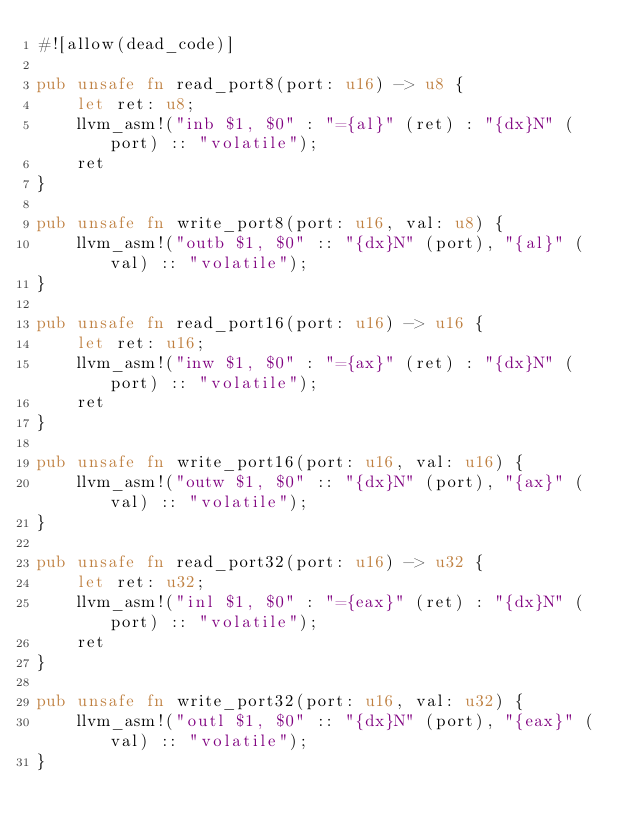Convert code to text. <code><loc_0><loc_0><loc_500><loc_500><_Rust_>#![allow(dead_code)]

pub unsafe fn read_port8(port: u16) -> u8 {
    let ret: u8;
    llvm_asm!("inb $1, $0" : "={al}" (ret) : "{dx}N" (port) :: "volatile");
    ret
}

pub unsafe fn write_port8(port: u16, val: u8) {
    llvm_asm!("outb $1, $0" :: "{dx}N" (port), "{al}" (val) :: "volatile");
}

pub unsafe fn read_port16(port: u16) -> u16 {
    let ret: u16;
    llvm_asm!("inw $1, $0" : "={ax}" (ret) : "{dx}N" (port) :: "volatile");
    ret
}

pub unsafe fn write_port16(port: u16, val: u16) {
    llvm_asm!("outw $1, $0" :: "{dx}N" (port), "{ax}" (val) :: "volatile");
}

pub unsafe fn read_port32(port: u16) -> u32 {
    let ret: u32;
    llvm_asm!("inl $1, $0" : "={eax}" (ret) : "{dx}N" (port) :: "volatile");
    ret
}

pub unsafe fn write_port32(port: u16, val: u32) {
    llvm_asm!("outl $1, $0" :: "{dx}N" (port), "{eax}" (val) :: "volatile");
}
</code> 